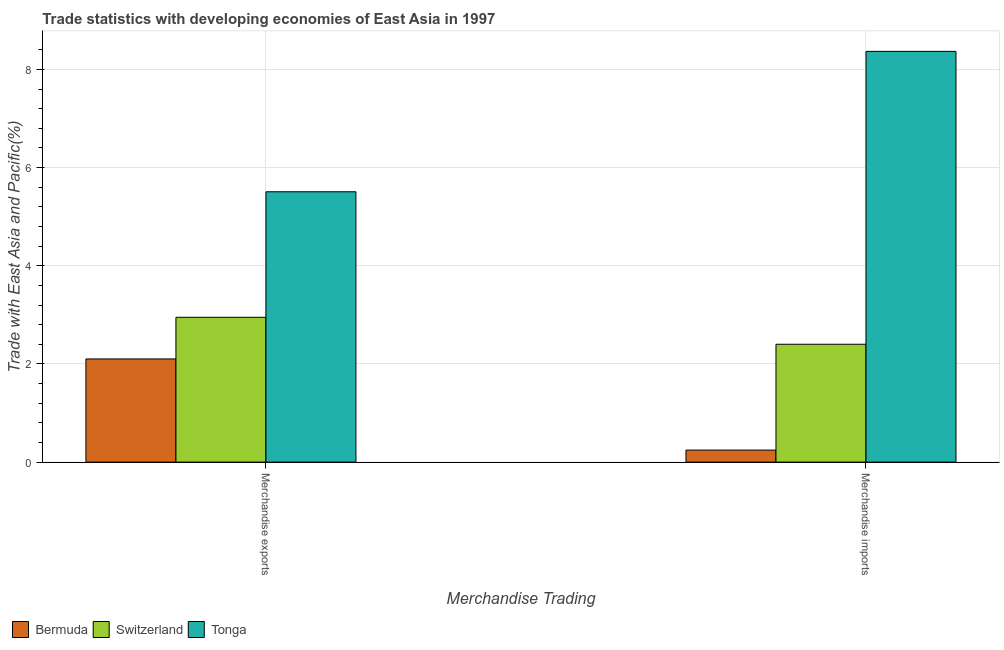How many different coloured bars are there?
Give a very brief answer. 3. How many groups of bars are there?
Provide a short and direct response. 2. How many bars are there on the 1st tick from the left?
Give a very brief answer. 3. What is the merchandise exports in Switzerland?
Give a very brief answer. 2.95. Across all countries, what is the maximum merchandise imports?
Offer a very short reply. 8.37. Across all countries, what is the minimum merchandise exports?
Ensure brevity in your answer.  2.1. In which country was the merchandise imports maximum?
Offer a terse response. Tonga. In which country was the merchandise exports minimum?
Keep it short and to the point. Bermuda. What is the total merchandise imports in the graph?
Your response must be concise. 11.01. What is the difference between the merchandise imports in Tonga and that in Bermuda?
Give a very brief answer. 8.12. What is the difference between the merchandise exports in Switzerland and the merchandise imports in Bermuda?
Offer a very short reply. 2.7. What is the average merchandise exports per country?
Ensure brevity in your answer.  3.52. What is the difference between the merchandise exports and merchandise imports in Switzerland?
Keep it short and to the point. 0.55. What is the ratio of the merchandise exports in Tonga to that in Switzerland?
Offer a terse response. 1.87. What does the 3rd bar from the left in Merchandise exports represents?
Provide a short and direct response. Tonga. What does the 3rd bar from the right in Merchandise exports represents?
Give a very brief answer. Bermuda. Are all the bars in the graph horizontal?
Offer a terse response. No. How many countries are there in the graph?
Your answer should be compact. 3. What is the difference between two consecutive major ticks on the Y-axis?
Your response must be concise. 2. How many legend labels are there?
Your answer should be compact. 3. How are the legend labels stacked?
Your answer should be very brief. Horizontal. What is the title of the graph?
Provide a short and direct response. Trade statistics with developing economies of East Asia in 1997. What is the label or title of the X-axis?
Offer a very short reply. Merchandise Trading. What is the label or title of the Y-axis?
Offer a terse response. Trade with East Asia and Pacific(%). What is the Trade with East Asia and Pacific(%) in Bermuda in Merchandise exports?
Make the answer very short. 2.1. What is the Trade with East Asia and Pacific(%) in Switzerland in Merchandise exports?
Offer a very short reply. 2.95. What is the Trade with East Asia and Pacific(%) in Tonga in Merchandise exports?
Offer a very short reply. 5.51. What is the Trade with East Asia and Pacific(%) in Bermuda in Merchandise imports?
Give a very brief answer. 0.25. What is the Trade with East Asia and Pacific(%) in Switzerland in Merchandise imports?
Ensure brevity in your answer.  2.4. What is the Trade with East Asia and Pacific(%) of Tonga in Merchandise imports?
Provide a succinct answer. 8.37. Across all Merchandise Trading, what is the maximum Trade with East Asia and Pacific(%) of Bermuda?
Offer a terse response. 2.1. Across all Merchandise Trading, what is the maximum Trade with East Asia and Pacific(%) in Switzerland?
Provide a succinct answer. 2.95. Across all Merchandise Trading, what is the maximum Trade with East Asia and Pacific(%) of Tonga?
Your answer should be very brief. 8.37. Across all Merchandise Trading, what is the minimum Trade with East Asia and Pacific(%) of Bermuda?
Offer a terse response. 0.25. Across all Merchandise Trading, what is the minimum Trade with East Asia and Pacific(%) in Switzerland?
Offer a very short reply. 2.4. Across all Merchandise Trading, what is the minimum Trade with East Asia and Pacific(%) in Tonga?
Give a very brief answer. 5.51. What is the total Trade with East Asia and Pacific(%) in Bermuda in the graph?
Offer a very short reply. 2.35. What is the total Trade with East Asia and Pacific(%) of Switzerland in the graph?
Ensure brevity in your answer.  5.35. What is the total Trade with East Asia and Pacific(%) in Tonga in the graph?
Provide a short and direct response. 13.87. What is the difference between the Trade with East Asia and Pacific(%) of Bermuda in Merchandise exports and that in Merchandise imports?
Your answer should be compact. 1.86. What is the difference between the Trade with East Asia and Pacific(%) of Switzerland in Merchandise exports and that in Merchandise imports?
Your response must be concise. 0.55. What is the difference between the Trade with East Asia and Pacific(%) in Tonga in Merchandise exports and that in Merchandise imports?
Keep it short and to the point. -2.86. What is the difference between the Trade with East Asia and Pacific(%) in Bermuda in Merchandise exports and the Trade with East Asia and Pacific(%) in Switzerland in Merchandise imports?
Give a very brief answer. -0.3. What is the difference between the Trade with East Asia and Pacific(%) in Bermuda in Merchandise exports and the Trade with East Asia and Pacific(%) in Tonga in Merchandise imports?
Keep it short and to the point. -6.26. What is the difference between the Trade with East Asia and Pacific(%) of Switzerland in Merchandise exports and the Trade with East Asia and Pacific(%) of Tonga in Merchandise imports?
Ensure brevity in your answer.  -5.42. What is the average Trade with East Asia and Pacific(%) of Bermuda per Merchandise Trading?
Your response must be concise. 1.17. What is the average Trade with East Asia and Pacific(%) of Switzerland per Merchandise Trading?
Make the answer very short. 2.68. What is the average Trade with East Asia and Pacific(%) in Tonga per Merchandise Trading?
Provide a short and direct response. 6.94. What is the difference between the Trade with East Asia and Pacific(%) in Bermuda and Trade with East Asia and Pacific(%) in Switzerland in Merchandise exports?
Offer a very short reply. -0.85. What is the difference between the Trade with East Asia and Pacific(%) in Bermuda and Trade with East Asia and Pacific(%) in Tonga in Merchandise exports?
Make the answer very short. -3.4. What is the difference between the Trade with East Asia and Pacific(%) of Switzerland and Trade with East Asia and Pacific(%) of Tonga in Merchandise exports?
Your response must be concise. -2.56. What is the difference between the Trade with East Asia and Pacific(%) of Bermuda and Trade with East Asia and Pacific(%) of Switzerland in Merchandise imports?
Ensure brevity in your answer.  -2.16. What is the difference between the Trade with East Asia and Pacific(%) in Bermuda and Trade with East Asia and Pacific(%) in Tonga in Merchandise imports?
Offer a very short reply. -8.12. What is the difference between the Trade with East Asia and Pacific(%) in Switzerland and Trade with East Asia and Pacific(%) in Tonga in Merchandise imports?
Provide a short and direct response. -5.97. What is the ratio of the Trade with East Asia and Pacific(%) in Bermuda in Merchandise exports to that in Merchandise imports?
Offer a terse response. 8.57. What is the ratio of the Trade with East Asia and Pacific(%) in Switzerland in Merchandise exports to that in Merchandise imports?
Provide a succinct answer. 1.23. What is the ratio of the Trade with East Asia and Pacific(%) of Tonga in Merchandise exports to that in Merchandise imports?
Your answer should be very brief. 0.66. What is the difference between the highest and the second highest Trade with East Asia and Pacific(%) of Bermuda?
Provide a short and direct response. 1.86. What is the difference between the highest and the second highest Trade with East Asia and Pacific(%) of Switzerland?
Ensure brevity in your answer.  0.55. What is the difference between the highest and the second highest Trade with East Asia and Pacific(%) in Tonga?
Provide a succinct answer. 2.86. What is the difference between the highest and the lowest Trade with East Asia and Pacific(%) of Bermuda?
Provide a short and direct response. 1.86. What is the difference between the highest and the lowest Trade with East Asia and Pacific(%) in Switzerland?
Your response must be concise. 0.55. What is the difference between the highest and the lowest Trade with East Asia and Pacific(%) in Tonga?
Your response must be concise. 2.86. 